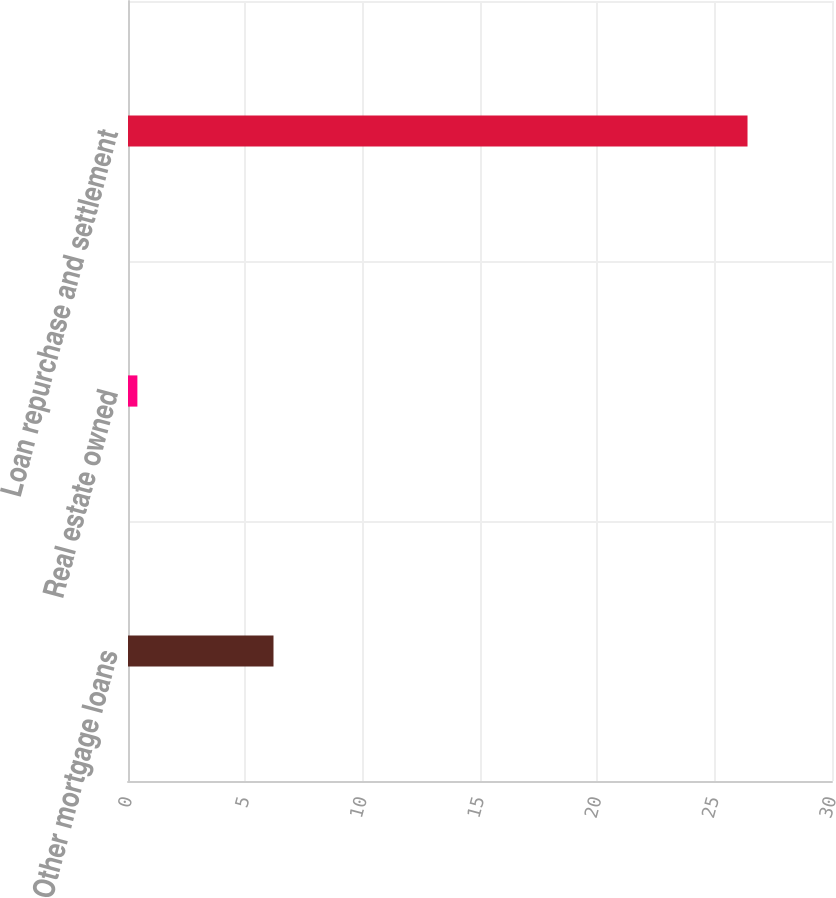Convert chart. <chart><loc_0><loc_0><loc_500><loc_500><bar_chart><fcel>Other mortgage loans<fcel>Real estate owned<fcel>Loan repurchase and settlement<nl><fcel>6.2<fcel>0.4<fcel>26.4<nl></chart> 